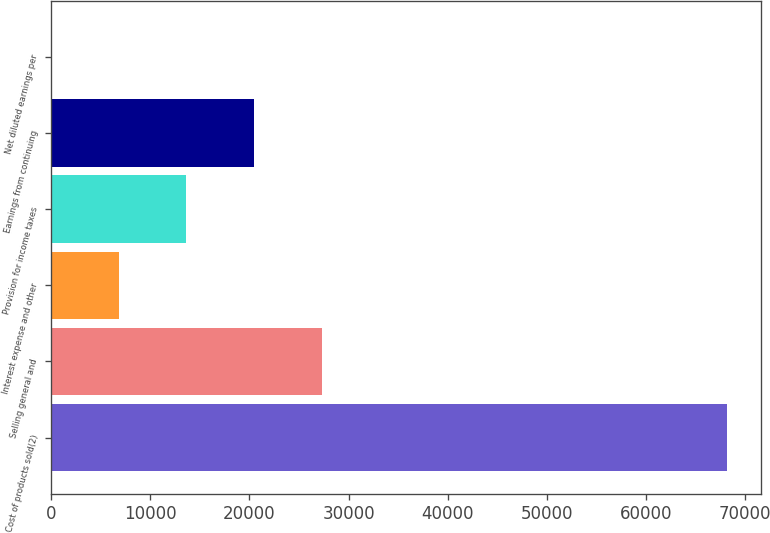<chart> <loc_0><loc_0><loc_500><loc_500><bar_chart><fcel>Cost of products sold(2)<fcel>Selling general and<fcel>Interest expense and other<fcel>Provision for income taxes<fcel>Earnings from continuing<fcel>Net diluted earnings per<nl><fcel>68206.3<fcel>27284<fcel>6822.8<fcel>13643.2<fcel>20463.6<fcel>2.41<nl></chart> 